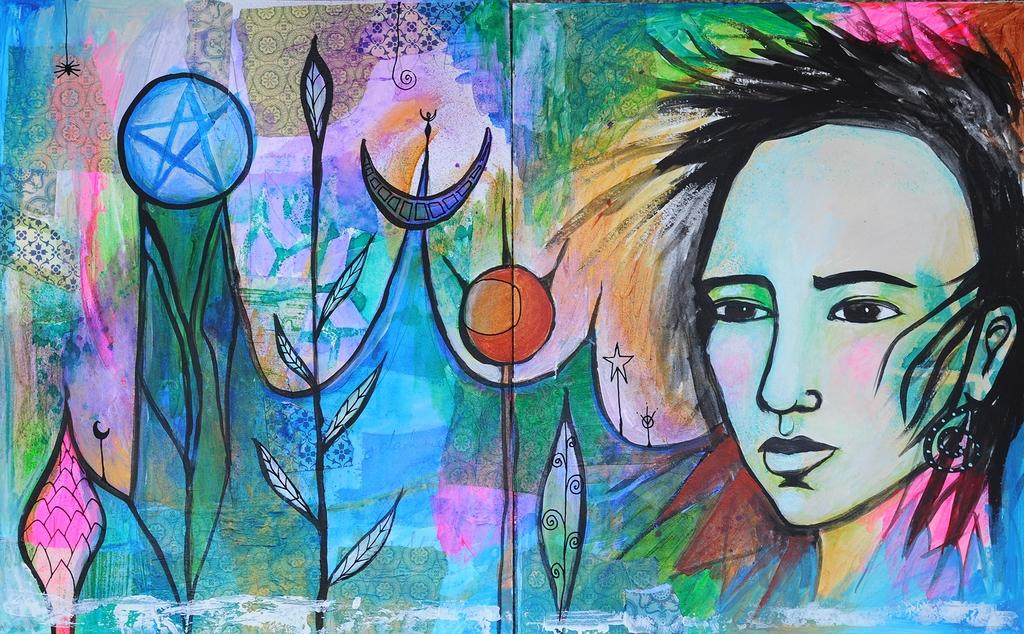What is present on the wall in the image? There is a painting on the wall in the image. What elements are included in the painting? The painting contains plants, a woman's face, and other designs. What type of produce is hanging from the woman's chin in the painting? There is no produce visible in the painting, nor is there any indication of a woman's chin. 